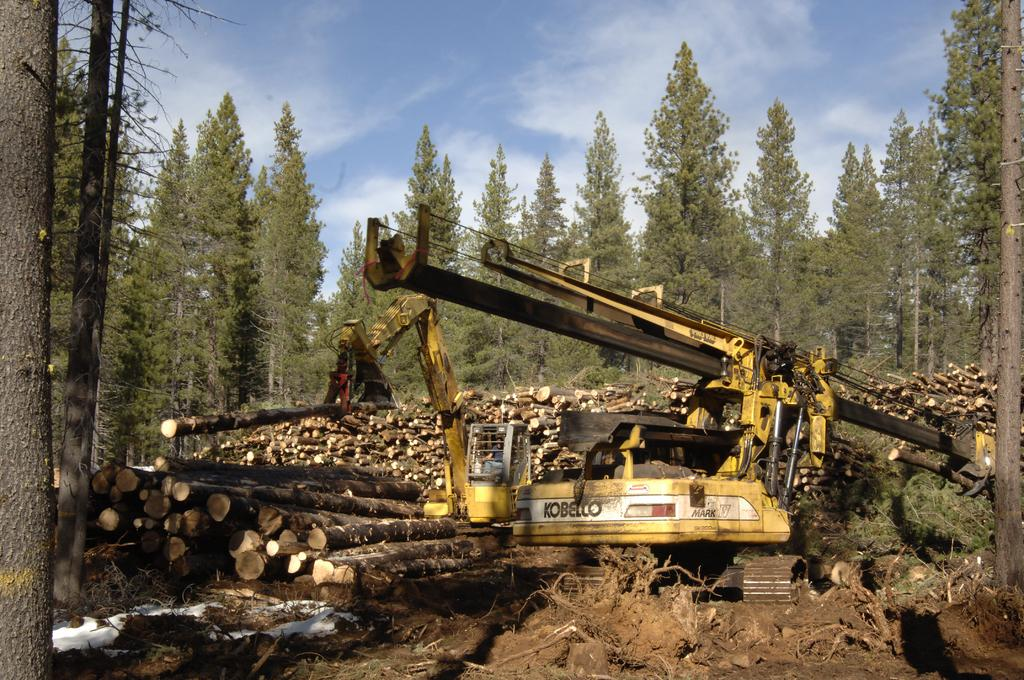<image>
Summarize the visual content of the image. A large yellow piece of logging machinery branded as Kobelco is surrounded by felled trees. 